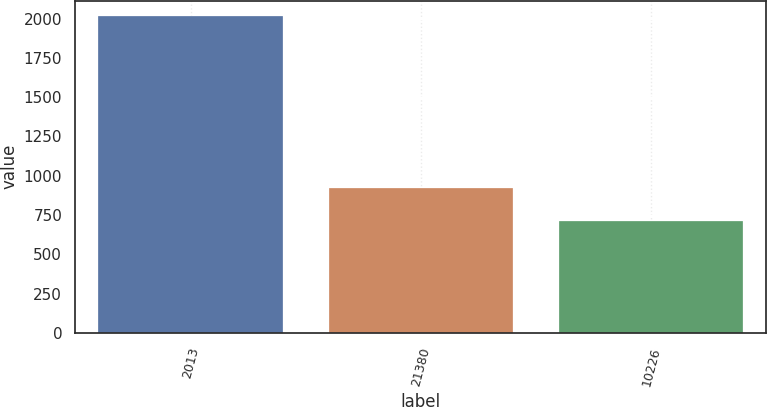<chart> <loc_0><loc_0><loc_500><loc_500><bar_chart><fcel>2013<fcel>21380<fcel>10226<nl><fcel>2013<fcel>924.7<fcel>712.1<nl></chart> 